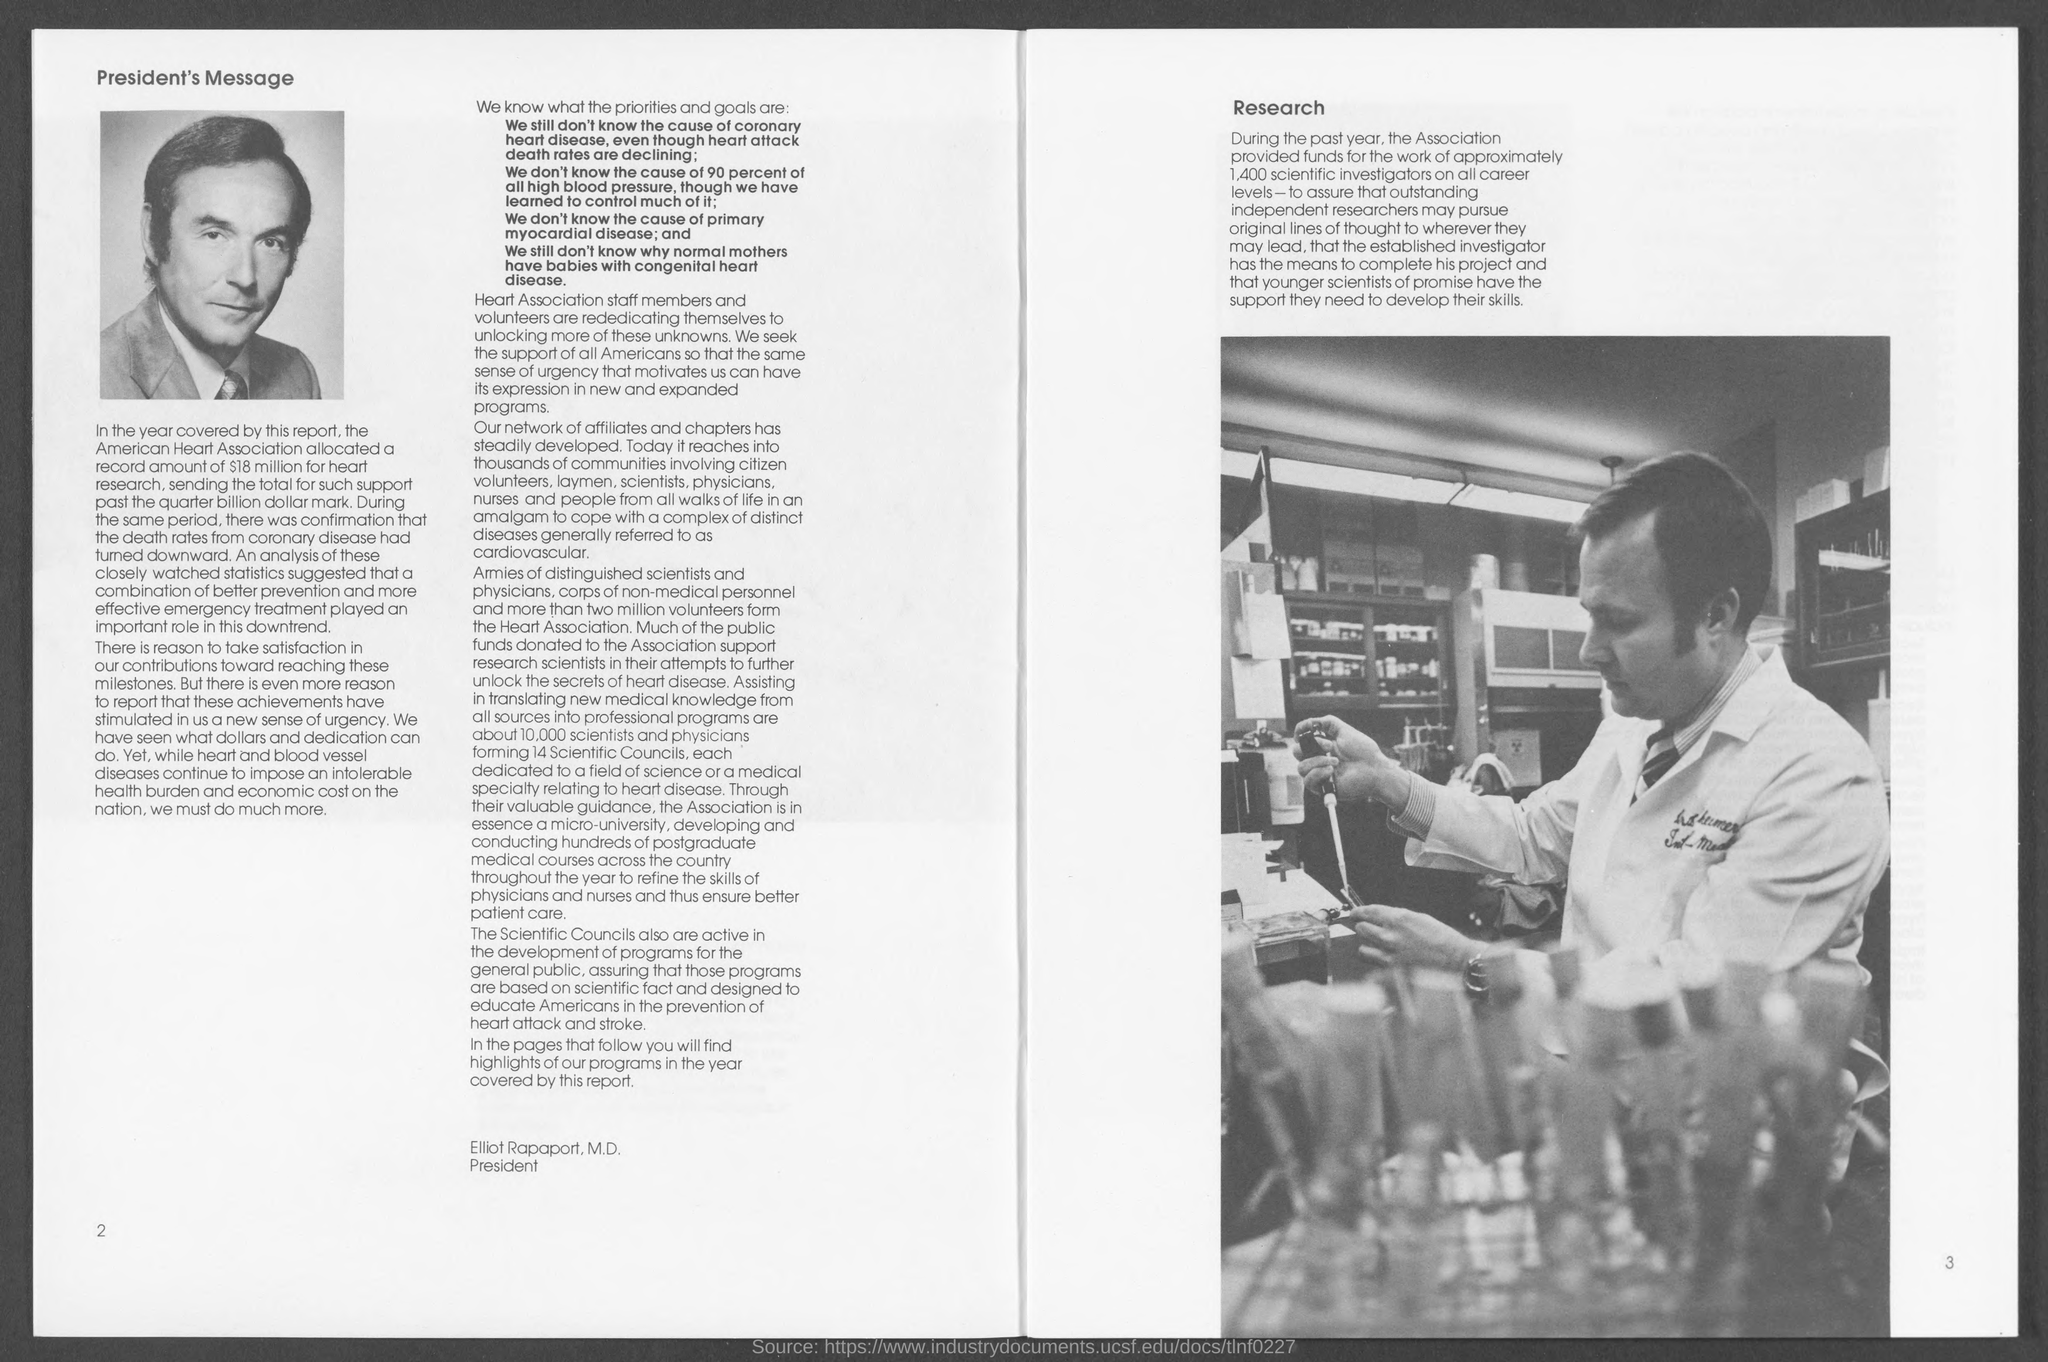What is written on the 'top left' corner of the first page?
Give a very brief answer. President's message. The association provided funds for how many scientific investigators?
Your answer should be very brief. 1,400. What is the amount allocated by American Heart  Asoociation for heart research?
Provide a succinct answer. 18 million. Which diseases continue to impose an intolerable health burden and ceonomic cost on the nation?
Give a very brief answer. Heart and blood vessel diseases. Which factors played an important role in the reduction of 'death rate from coronary diseases' ?
Offer a very short reply. Combination of better prevention and more effective emergency treatment. As per the document how may "Scientific Councils" formed?
Provide a short and direct response. 14 Scientific Councils. What is the name of the president?
Your answer should be compact. Elliot Rapaport, M.D. 